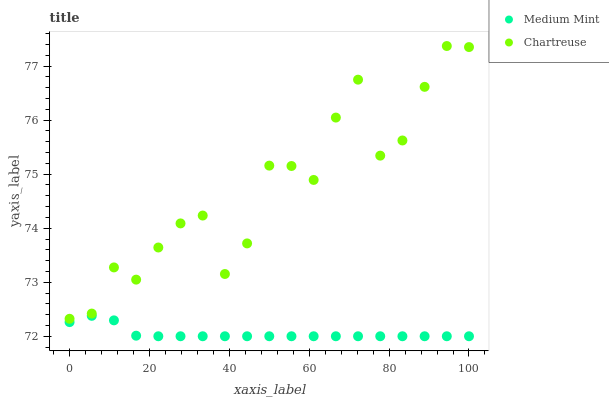Does Medium Mint have the minimum area under the curve?
Answer yes or no. Yes. Does Chartreuse have the maximum area under the curve?
Answer yes or no. Yes. Does Chartreuse have the minimum area under the curve?
Answer yes or no. No. Is Medium Mint the smoothest?
Answer yes or no. Yes. Is Chartreuse the roughest?
Answer yes or no. Yes. Is Chartreuse the smoothest?
Answer yes or no. No. Does Medium Mint have the lowest value?
Answer yes or no. Yes. Does Chartreuse have the lowest value?
Answer yes or no. No. Does Chartreuse have the highest value?
Answer yes or no. Yes. Is Medium Mint less than Chartreuse?
Answer yes or no. Yes. Is Chartreuse greater than Medium Mint?
Answer yes or no. Yes. Does Medium Mint intersect Chartreuse?
Answer yes or no. No. 